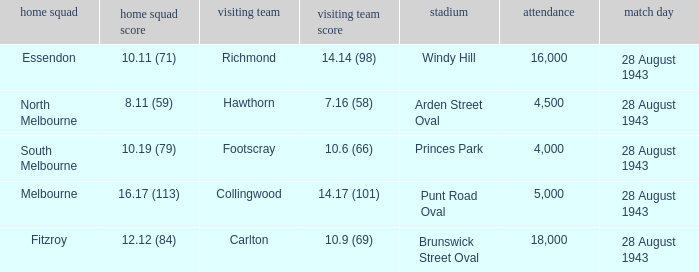Where was the game played with an away team score of 14.17 (101)? Punt Road Oval. 